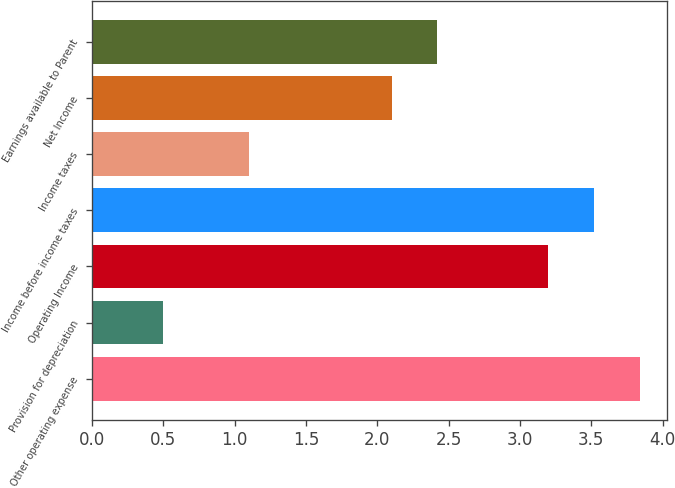Convert chart to OTSL. <chart><loc_0><loc_0><loc_500><loc_500><bar_chart><fcel>Other operating expense<fcel>Provision for depreciation<fcel>Operating Income<fcel>Income before income taxes<fcel>Income taxes<fcel>Net Income<fcel>Earnings available to Parent<nl><fcel>3.84<fcel>0.5<fcel>3.2<fcel>3.52<fcel>1.1<fcel>2.1<fcel>2.42<nl></chart> 